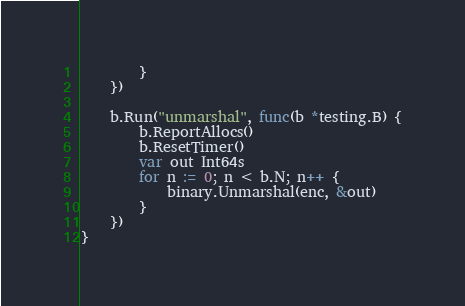<code> <loc_0><loc_0><loc_500><loc_500><_Go_>		}
	})

	b.Run("unmarshal", func(b *testing.B) {
		b.ReportAllocs()
		b.ResetTimer()
		var out Int64s
		for n := 0; n < b.N; n++ {
			binary.Unmarshal(enc, &out)
		}
	})
}
</code> 